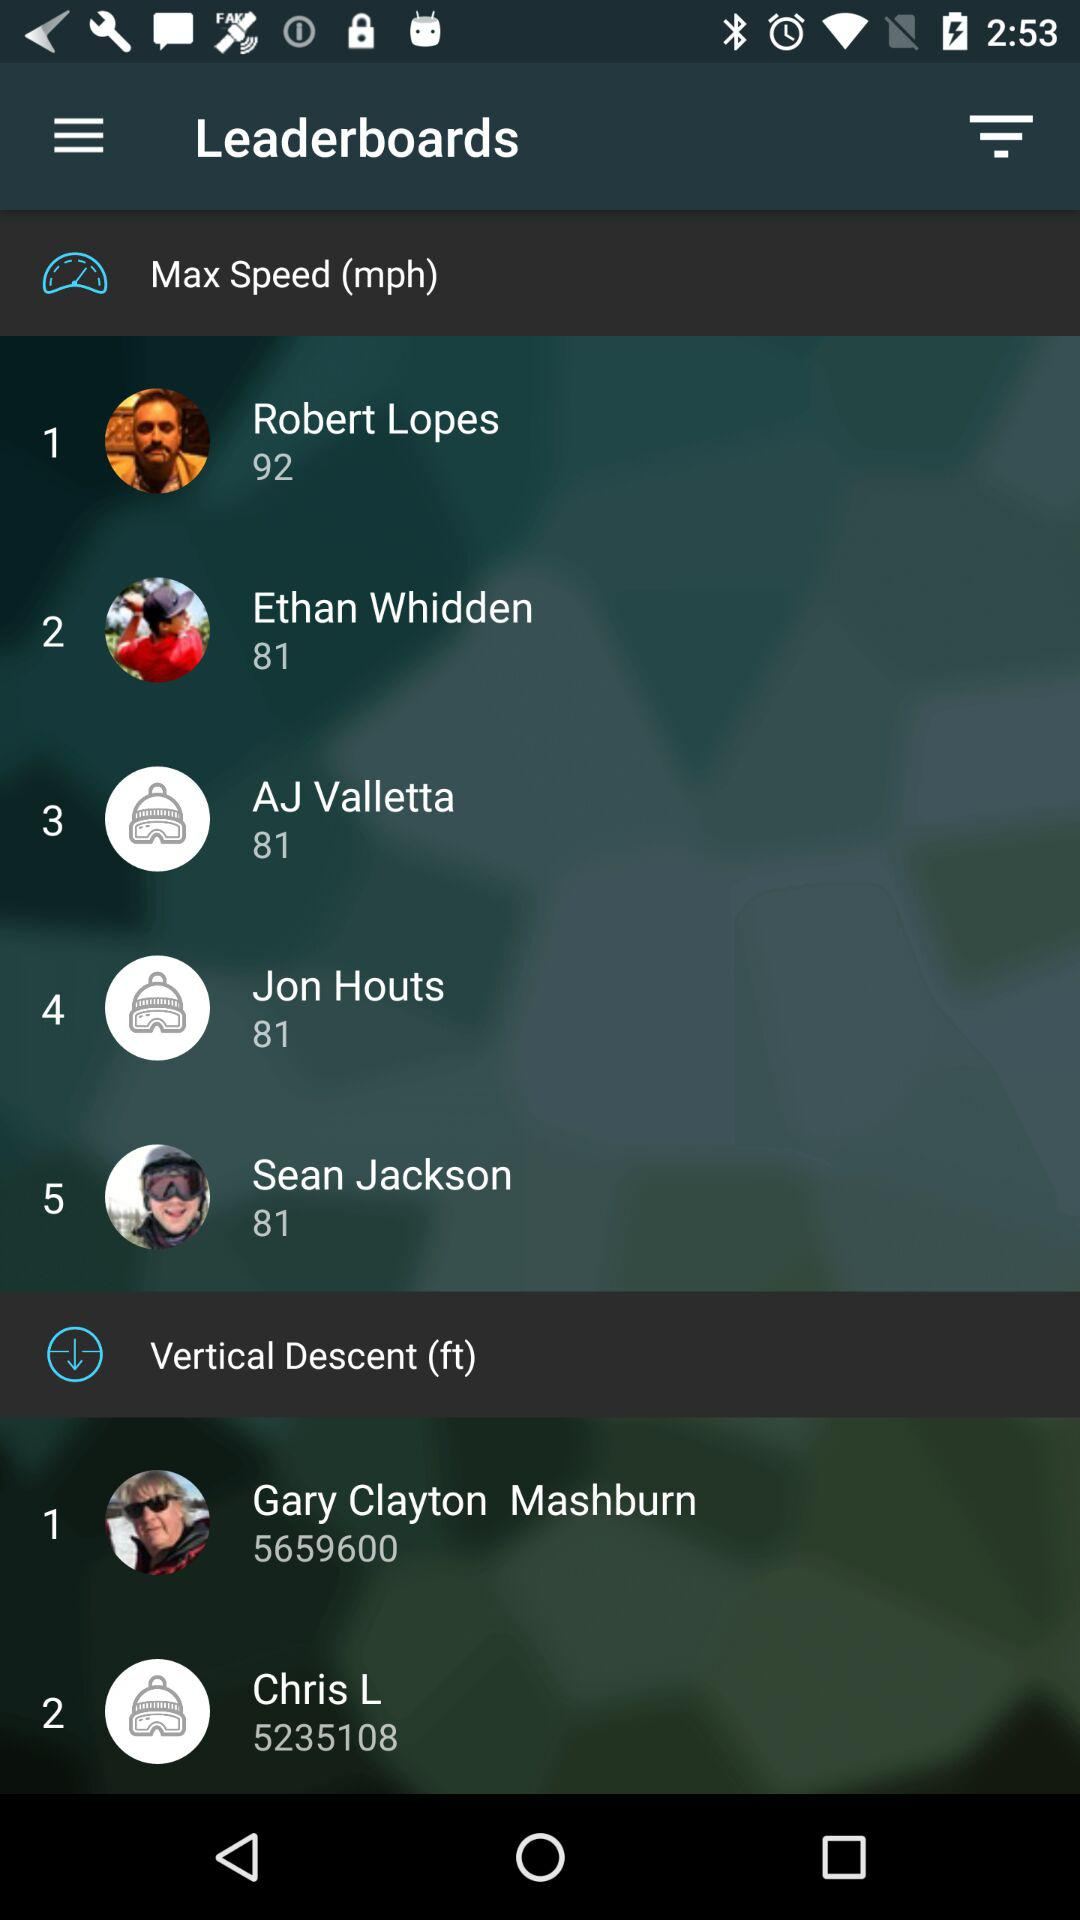How many people have completed the course?
Answer the question using a single word or phrase. 5 